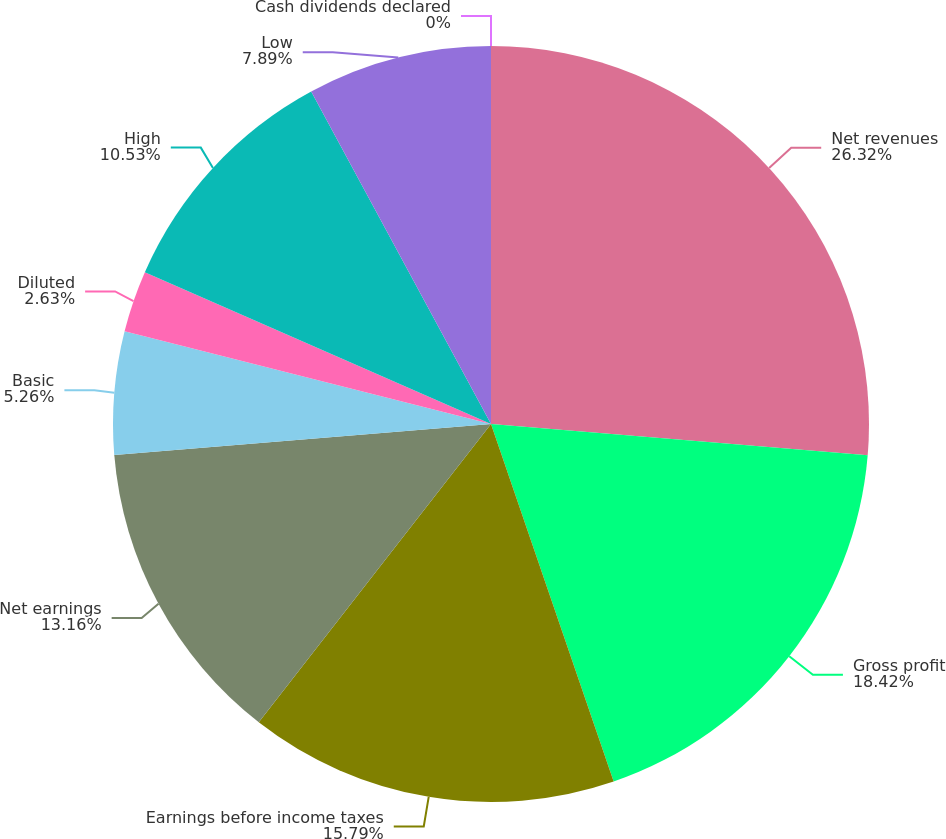<chart> <loc_0><loc_0><loc_500><loc_500><pie_chart><fcel>Net revenues<fcel>Gross profit<fcel>Earnings before income taxes<fcel>Net earnings<fcel>Basic<fcel>Diluted<fcel>High<fcel>Low<fcel>Cash dividends declared<nl><fcel>26.32%<fcel>18.42%<fcel>15.79%<fcel>13.16%<fcel>5.26%<fcel>2.63%<fcel>10.53%<fcel>7.89%<fcel>0.0%<nl></chart> 